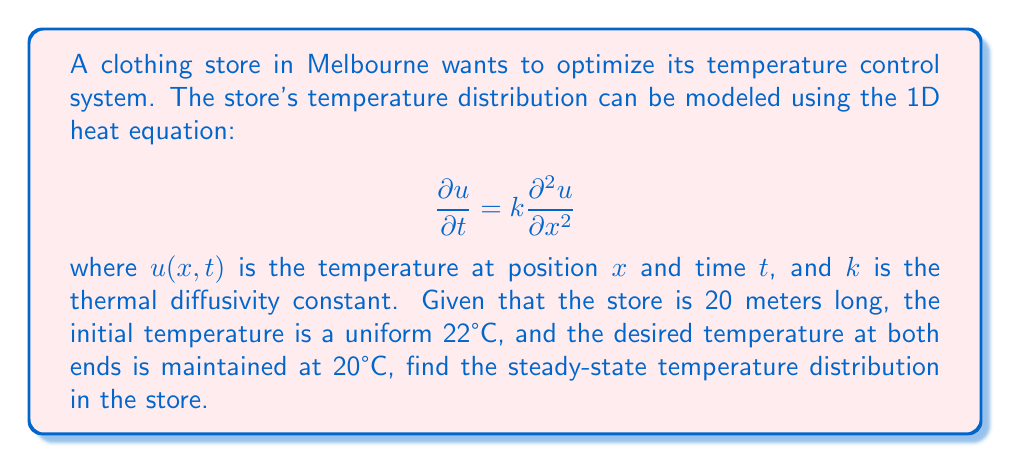Can you solve this math problem? To solve this problem, we need to follow these steps:

1) For the steady-state solution, the temperature doesn't change with time. So, we set $\frac{\partial u}{\partial t} = 0$:

   $$0 = k\frac{\partial^2 u}{\partial x^2}$$

2) This simplifies to:

   $$\frac{d^2u}{dx^2} = 0$$

3) Integrating twice:

   $$\frac{du}{dx} = C_1$$
   $$u = C_1x + C_2$$

4) Now, we apply the boundary conditions:
   At $x = 0$, $u = 20$
   At $x = 20$, $u = 20$

5) Substituting these into our equation:

   $20 = C_2$
   $20 = 20C_1 + 20$

6) From the second equation:
   $0 = 20C_1$
   $C_1 = 0$

7) Therefore, our steady-state solution is:

   $$u(x) = 20$$

This means that at steady-state, the temperature throughout the store will be a uniform 20°C, regardless of position.
Answer: $u(x) = 20°C$ 